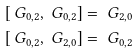<formula> <loc_0><loc_0><loc_500><loc_500>& [ \ G _ { 0 , 2 } , \ G _ { 0 , 2 } ] = \ G _ { 2 , 0 } \\ & [ \ G _ { 0 , 2 } , \ G _ { 2 , 0 } ] = \ G _ { 0 , 2 }</formula> 